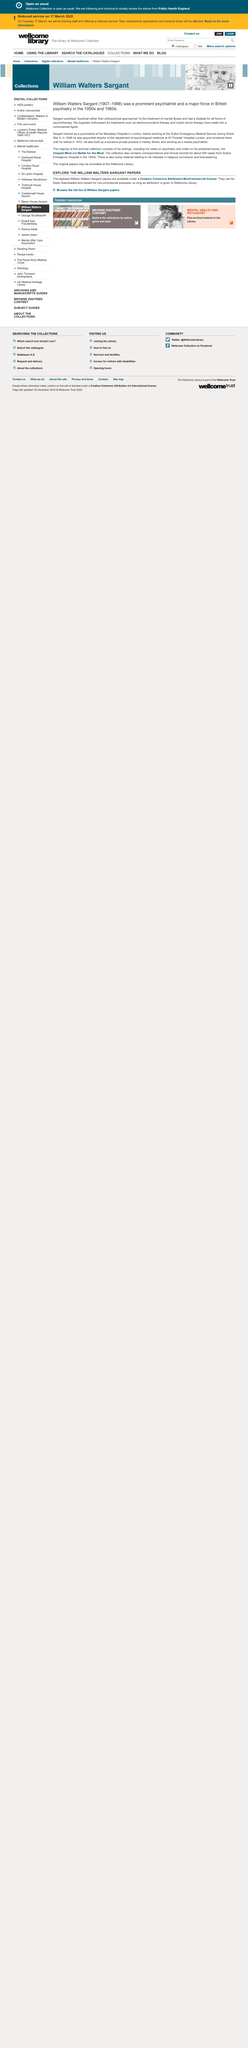List a handful of essential elements in this visual. William Walters Sargant retired in 1972. It is known that William Walters Sargant was born in 1907. William Walters Sargant received his training as a psychiatrist at Maudsley Hospital in London. 